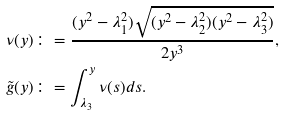<formula> <loc_0><loc_0><loc_500><loc_500>\nu ( y ) & \colon = \frac { ( y ^ { 2 } - \lambda _ { 1 } ^ { 2 } ) \sqrt { ( y ^ { 2 } - \lambda _ { 2 } ^ { 2 } ) ( y ^ { 2 } - \lambda _ { 3 } ^ { 2 } ) } } { 2 y ^ { 3 } } , \\ \tilde { g } ( y ) & \colon = \int _ { \lambda _ { 3 } } ^ { y } \nu ( s ) d s .</formula> 